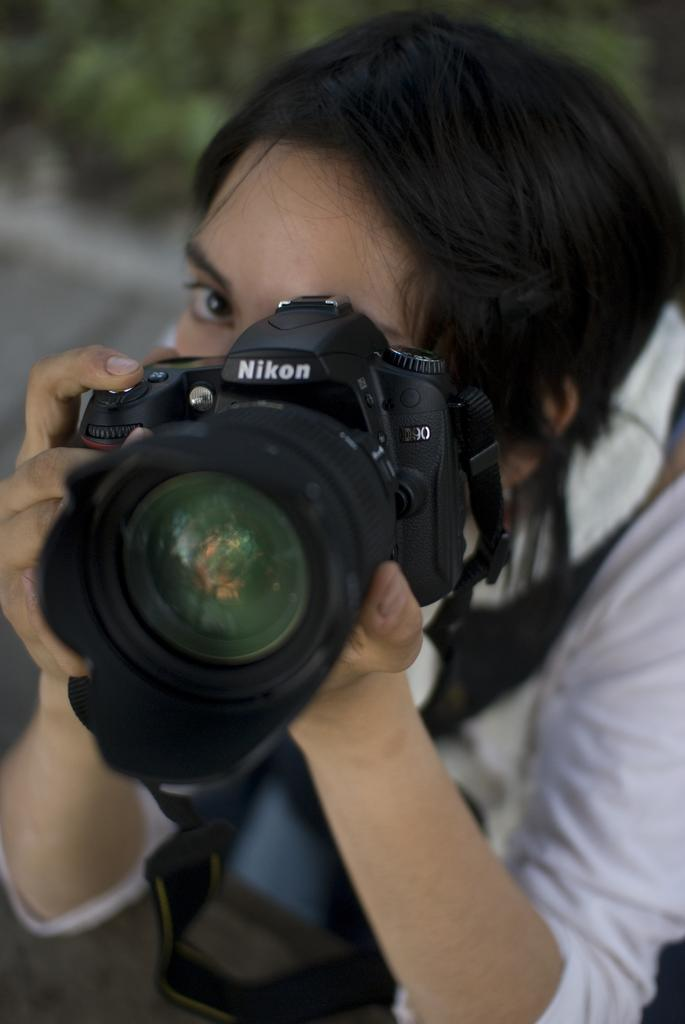Who is the main subject in the image? There is a woman in the image. What is the woman holding in her hands? The woman is holding a camera in her hands. What type of rice is being cooked in the image? There is no rice present in the image; it features a woman holding a camera. How many chickens can be seen in the image? There are no chickens present in the image; it features a woman holding a camera. 